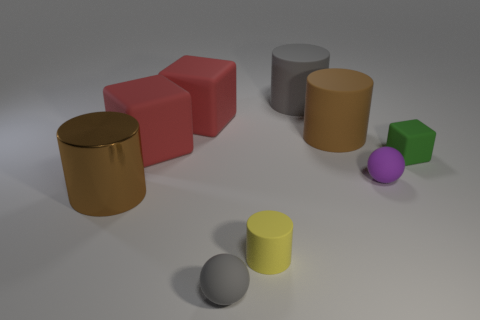Add 1 large metal things. How many objects exist? 10 Subtract all blocks. How many objects are left? 6 Subtract all small purple matte balls. Subtract all red rubber objects. How many objects are left? 6 Add 4 gray cylinders. How many gray cylinders are left? 5 Add 9 tiny yellow shiny blocks. How many tiny yellow shiny blocks exist? 9 Subtract 2 red blocks. How many objects are left? 7 